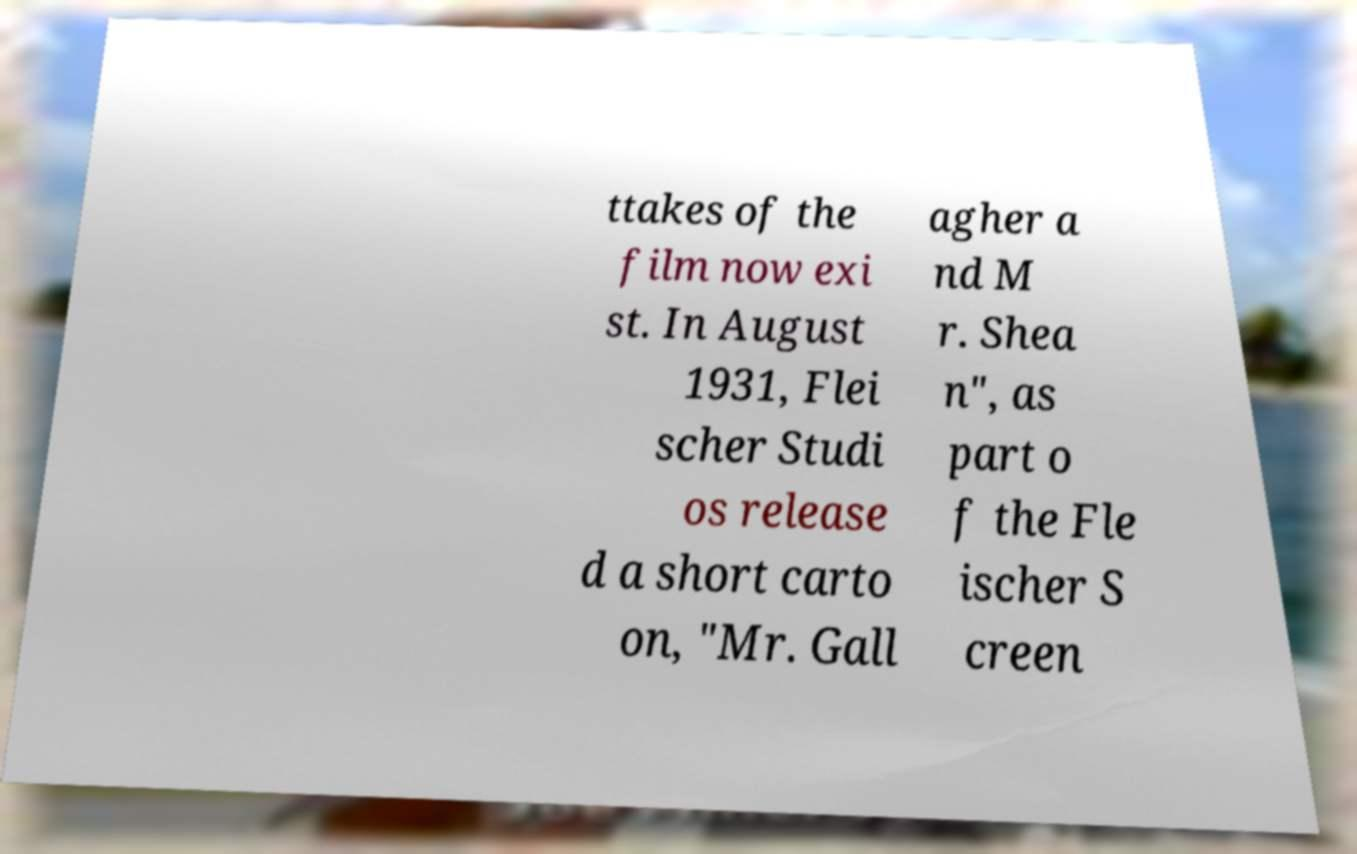For documentation purposes, I need the text within this image transcribed. Could you provide that? ttakes of the film now exi st. In August 1931, Flei scher Studi os release d a short carto on, "Mr. Gall agher a nd M r. Shea n", as part o f the Fle ischer S creen 